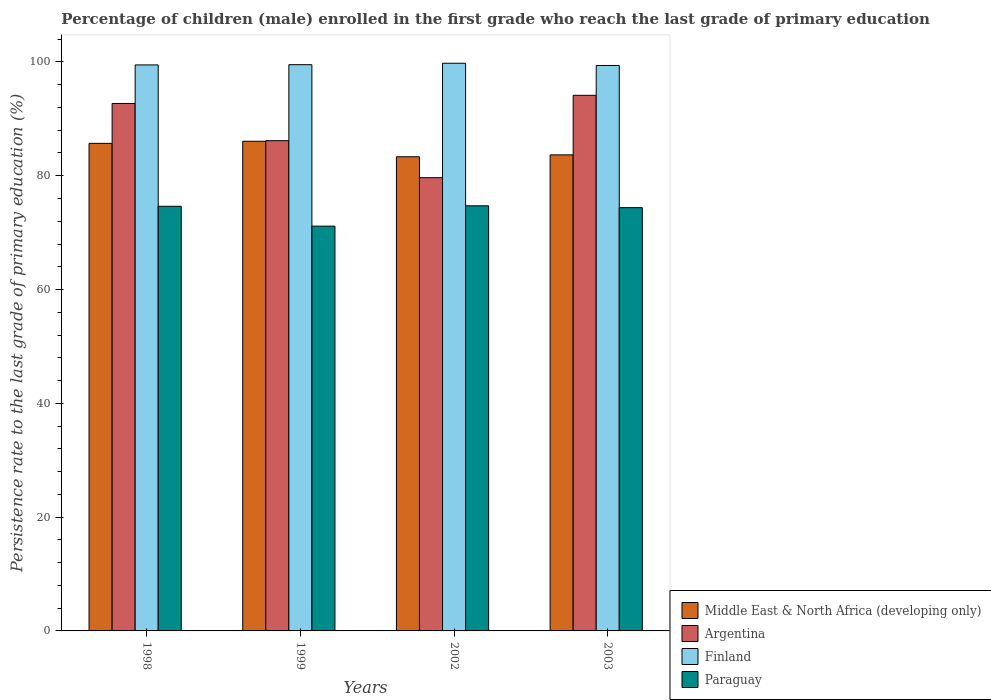How many groups of bars are there?
Make the answer very short. 4. Are the number of bars per tick equal to the number of legend labels?
Make the answer very short. Yes. How many bars are there on the 1st tick from the left?
Offer a terse response. 4. What is the label of the 1st group of bars from the left?
Keep it short and to the point. 1998. In how many cases, is the number of bars for a given year not equal to the number of legend labels?
Your answer should be very brief. 0. What is the persistence rate of children in Finland in 2003?
Provide a succinct answer. 99.38. Across all years, what is the maximum persistence rate of children in Finland?
Provide a succinct answer. 99.77. Across all years, what is the minimum persistence rate of children in Finland?
Offer a very short reply. 99.38. In which year was the persistence rate of children in Paraguay maximum?
Offer a terse response. 2002. In which year was the persistence rate of children in Finland minimum?
Keep it short and to the point. 2003. What is the total persistence rate of children in Paraguay in the graph?
Make the answer very short. 294.88. What is the difference between the persistence rate of children in Paraguay in 1998 and that in 2002?
Keep it short and to the point. -0.09. What is the difference between the persistence rate of children in Middle East & North Africa (developing only) in 2003 and the persistence rate of children in Finland in 1998?
Keep it short and to the point. -15.81. What is the average persistence rate of children in Argentina per year?
Make the answer very short. 88.16. In the year 1998, what is the difference between the persistence rate of children in Paraguay and persistence rate of children in Finland?
Offer a very short reply. -24.85. In how many years, is the persistence rate of children in Finland greater than 32 %?
Offer a very short reply. 4. What is the ratio of the persistence rate of children in Middle East & North Africa (developing only) in 1999 to that in 2002?
Ensure brevity in your answer.  1.03. What is the difference between the highest and the second highest persistence rate of children in Finland?
Offer a terse response. 0.25. What is the difference between the highest and the lowest persistence rate of children in Finland?
Ensure brevity in your answer.  0.39. In how many years, is the persistence rate of children in Paraguay greater than the average persistence rate of children in Paraguay taken over all years?
Provide a short and direct response. 3. Is the sum of the persistence rate of children in Middle East & North Africa (developing only) in 1998 and 1999 greater than the maximum persistence rate of children in Argentina across all years?
Ensure brevity in your answer.  Yes. Is it the case that in every year, the sum of the persistence rate of children in Middle East & North Africa (developing only) and persistence rate of children in Finland is greater than the sum of persistence rate of children in Paraguay and persistence rate of children in Argentina?
Your answer should be very brief. No. What does the 4th bar from the left in 2003 represents?
Offer a very short reply. Paraguay. What does the 4th bar from the right in 2002 represents?
Offer a very short reply. Middle East & North Africa (developing only). Are all the bars in the graph horizontal?
Offer a very short reply. No. How many years are there in the graph?
Your answer should be very brief. 4. What is the difference between two consecutive major ticks on the Y-axis?
Offer a terse response. 20. Does the graph contain any zero values?
Offer a very short reply. No. Does the graph contain grids?
Provide a short and direct response. No. Where does the legend appear in the graph?
Offer a terse response. Bottom right. How many legend labels are there?
Provide a succinct answer. 4. What is the title of the graph?
Your answer should be very brief. Percentage of children (male) enrolled in the first grade who reach the last grade of primary education. Does "Egypt, Arab Rep." appear as one of the legend labels in the graph?
Ensure brevity in your answer.  No. What is the label or title of the Y-axis?
Give a very brief answer. Persistence rate to the last grade of primary education (%). What is the Persistence rate to the last grade of primary education (%) of Middle East & North Africa (developing only) in 1998?
Your answer should be compact. 85.69. What is the Persistence rate to the last grade of primary education (%) of Argentina in 1998?
Give a very brief answer. 92.7. What is the Persistence rate to the last grade of primary education (%) of Finland in 1998?
Ensure brevity in your answer.  99.48. What is the Persistence rate to the last grade of primary education (%) of Paraguay in 1998?
Give a very brief answer. 74.63. What is the Persistence rate to the last grade of primary education (%) in Middle East & North Africa (developing only) in 1999?
Your answer should be compact. 86.06. What is the Persistence rate to the last grade of primary education (%) of Argentina in 1999?
Provide a short and direct response. 86.16. What is the Persistence rate to the last grade of primary education (%) of Finland in 1999?
Provide a succinct answer. 99.52. What is the Persistence rate to the last grade of primary education (%) of Paraguay in 1999?
Keep it short and to the point. 71.14. What is the Persistence rate to the last grade of primary education (%) in Middle East & North Africa (developing only) in 2002?
Your answer should be compact. 83.33. What is the Persistence rate to the last grade of primary education (%) of Argentina in 2002?
Keep it short and to the point. 79.66. What is the Persistence rate to the last grade of primary education (%) of Finland in 2002?
Your response must be concise. 99.77. What is the Persistence rate to the last grade of primary education (%) of Paraguay in 2002?
Ensure brevity in your answer.  74.72. What is the Persistence rate to the last grade of primary education (%) of Middle East & North Africa (developing only) in 2003?
Offer a very short reply. 83.67. What is the Persistence rate to the last grade of primary education (%) of Argentina in 2003?
Your response must be concise. 94.14. What is the Persistence rate to the last grade of primary education (%) of Finland in 2003?
Offer a terse response. 99.38. What is the Persistence rate to the last grade of primary education (%) in Paraguay in 2003?
Make the answer very short. 74.39. Across all years, what is the maximum Persistence rate to the last grade of primary education (%) of Middle East & North Africa (developing only)?
Your answer should be compact. 86.06. Across all years, what is the maximum Persistence rate to the last grade of primary education (%) in Argentina?
Keep it short and to the point. 94.14. Across all years, what is the maximum Persistence rate to the last grade of primary education (%) of Finland?
Your response must be concise. 99.77. Across all years, what is the maximum Persistence rate to the last grade of primary education (%) in Paraguay?
Ensure brevity in your answer.  74.72. Across all years, what is the minimum Persistence rate to the last grade of primary education (%) in Middle East & North Africa (developing only)?
Make the answer very short. 83.33. Across all years, what is the minimum Persistence rate to the last grade of primary education (%) in Argentina?
Provide a short and direct response. 79.66. Across all years, what is the minimum Persistence rate to the last grade of primary education (%) of Finland?
Your answer should be compact. 99.38. Across all years, what is the minimum Persistence rate to the last grade of primary education (%) of Paraguay?
Give a very brief answer. 71.14. What is the total Persistence rate to the last grade of primary education (%) of Middle East & North Africa (developing only) in the graph?
Make the answer very short. 338.76. What is the total Persistence rate to the last grade of primary education (%) in Argentina in the graph?
Offer a very short reply. 352.66. What is the total Persistence rate to the last grade of primary education (%) in Finland in the graph?
Give a very brief answer. 398.14. What is the total Persistence rate to the last grade of primary education (%) of Paraguay in the graph?
Ensure brevity in your answer.  294.88. What is the difference between the Persistence rate to the last grade of primary education (%) of Middle East & North Africa (developing only) in 1998 and that in 1999?
Give a very brief answer. -0.37. What is the difference between the Persistence rate to the last grade of primary education (%) of Argentina in 1998 and that in 1999?
Your answer should be compact. 6.54. What is the difference between the Persistence rate to the last grade of primary education (%) of Finland in 1998 and that in 1999?
Make the answer very short. -0.04. What is the difference between the Persistence rate to the last grade of primary education (%) of Paraguay in 1998 and that in 1999?
Make the answer very short. 3.49. What is the difference between the Persistence rate to the last grade of primary education (%) in Middle East & North Africa (developing only) in 1998 and that in 2002?
Provide a short and direct response. 2.36. What is the difference between the Persistence rate to the last grade of primary education (%) in Argentina in 1998 and that in 2002?
Ensure brevity in your answer.  13.04. What is the difference between the Persistence rate to the last grade of primary education (%) in Finland in 1998 and that in 2002?
Make the answer very short. -0.29. What is the difference between the Persistence rate to the last grade of primary education (%) in Paraguay in 1998 and that in 2002?
Make the answer very short. -0.09. What is the difference between the Persistence rate to the last grade of primary education (%) in Middle East & North Africa (developing only) in 1998 and that in 2003?
Provide a succinct answer. 2.02. What is the difference between the Persistence rate to the last grade of primary education (%) of Argentina in 1998 and that in 2003?
Your answer should be compact. -1.43. What is the difference between the Persistence rate to the last grade of primary education (%) of Finland in 1998 and that in 2003?
Provide a short and direct response. 0.1. What is the difference between the Persistence rate to the last grade of primary education (%) of Paraguay in 1998 and that in 2003?
Give a very brief answer. 0.24. What is the difference between the Persistence rate to the last grade of primary education (%) in Middle East & North Africa (developing only) in 1999 and that in 2002?
Your answer should be very brief. 2.73. What is the difference between the Persistence rate to the last grade of primary education (%) of Argentina in 1999 and that in 2002?
Keep it short and to the point. 6.5. What is the difference between the Persistence rate to the last grade of primary education (%) of Finland in 1999 and that in 2002?
Provide a short and direct response. -0.25. What is the difference between the Persistence rate to the last grade of primary education (%) of Paraguay in 1999 and that in 2002?
Keep it short and to the point. -3.57. What is the difference between the Persistence rate to the last grade of primary education (%) of Middle East & North Africa (developing only) in 1999 and that in 2003?
Provide a short and direct response. 2.39. What is the difference between the Persistence rate to the last grade of primary education (%) in Argentina in 1999 and that in 2003?
Offer a terse response. -7.97. What is the difference between the Persistence rate to the last grade of primary education (%) of Finland in 1999 and that in 2003?
Provide a short and direct response. 0.14. What is the difference between the Persistence rate to the last grade of primary education (%) of Paraguay in 1999 and that in 2003?
Give a very brief answer. -3.25. What is the difference between the Persistence rate to the last grade of primary education (%) in Middle East & North Africa (developing only) in 2002 and that in 2003?
Give a very brief answer. -0.34. What is the difference between the Persistence rate to the last grade of primary education (%) in Argentina in 2002 and that in 2003?
Offer a very short reply. -14.48. What is the difference between the Persistence rate to the last grade of primary education (%) of Finland in 2002 and that in 2003?
Give a very brief answer. 0.39. What is the difference between the Persistence rate to the last grade of primary education (%) of Paraguay in 2002 and that in 2003?
Your response must be concise. 0.33. What is the difference between the Persistence rate to the last grade of primary education (%) of Middle East & North Africa (developing only) in 1998 and the Persistence rate to the last grade of primary education (%) of Argentina in 1999?
Give a very brief answer. -0.47. What is the difference between the Persistence rate to the last grade of primary education (%) of Middle East & North Africa (developing only) in 1998 and the Persistence rate to the last grade of primary education (%) of Finland in 1999?
Ensure brevity in your answer.  -13.83. What is the difference between the Persistence rate to the last grade of primary education (%) in Middle East & North Africa (developing only) in 1998 and the Persistence rate to the last grade of primary education (%) in Paraguay in 1999?
Give a very brief answer. 14.55. What is the difference between the Persistence rate to the last grade of primary education (%) of Argentina in 1998 and the Persistence rate to the last grade of primary education (%) of Finland in 1999?
Provide a short and direct response. -6.82. What is the difference between the Persistence rate to the last grade of primary education (%) of Argentina in 1998 and the Persistence rate to the last grade of primary education (%) of Paraguay in 1999?
Your answer should be compact. 21.56. What is the difference between the Persistence rate to the last grade of primary education (%) in Finland in 1998 and the Persistence rate to the last grade of primary education (%) in Paraguay in 1999?
Your answer should be compact. 28.34. What is the difference between the Persistence rate to the last grade of primary education (%) of Middle East & North Africa (developing only) in 1998 and the Persistence rate to the last grade of primary education (%) of Argentina in 2002?
Make the answer very short. 6.03. What is the difference between the Persistence rate to the last grade of primary education (%) of Middle East & North Africa (developing only) in 1998 and the Persistence rate to the last grade of primary education (%) of Finland in 2002?
Make the answer very short. -14.08. What is the difference between the Persistence rate to the last grade of primary education (%) in Middle East & North Africa (developing only) in 1998 and the Persistence rate to the last grade of primary education (%) in Paraguay in 2002?
Provide a succinct answer. 10.97. What is the difference between the Persistence rate to the last grade of primary education (%) of Argentina in 1998 and the Persistence rate to the last grade of primary education (%) of Finland in 2002?
Give a very brief answer. -7.07. What is the difference between the Persistence rate to the last grade of primary education (%) of Argentina in 1998 and the Persistence rate to the last grade of primary education (%) of Paraguay in 2002?
Your answer should be compact. 17.98. What is the difference between the Persistence rate to the last grade of primary education (%) of Finland in 1998 and the Persistence rate to the last grade of primary education (%) of Paraguay in 2002?
Give a very brief answer. 24.76. What is the difference between the Persistence rate to the last grade of primary education (%) in Middle East & North Africa (developing only) in 1998 and the Persistence rate to the last grade of primary education (%) in Argentina in 2003?
Make the answer very short. -8.45. What is the difference between the Persistence rate to the last grade of primary education (%) of Middle East & North Africa (developing only) in 1998 and the Persistence rate to the last grade of primary education (%) of Finland in 2003?
Make the answer very short. -13.69. What is the difference between the Persistence rate to the last grade of primary education (%) in Argentina in 1998 and the Persistence rate to the last grade of primary education (%) in Finland in 2003?
Your response must be concise. -6.68. What is the difference between the Persistence rate to the last grade of primary education (%) in Argentina in 1998 and the Persistence rate to the last grade of primary education (%) in Paraguay in 2003?
Provide a short and direct response. 18.31. What is the difference between the Persistence rate to the last grade of primary education (%) of Finland in 1998 and the Persistence rate to the last grade of primary education (%) of Paraguay in 2003?
Give a very brief answer. 25.09. What is the difference between the Persistence rate to the last grade of primary education (%) of Middle East & North Africa (developing only) in 1999 and the Persistence rate to the last grade of primary education (%) of Argentina in 2002?
Give a very brief answer. 6.4. What is the difference between the Persistence rate to the last grade of primary education (%) in Middle East & North Africa (developing only) in 1999 and the Persistence rate to the last grade of primary education (%) in Finland in 2002?
Make the answer very short. -13.71. What is the difference between the Persistence rate to the last grade of primary education (%) of Middle East & North Africa (developing only) in 1999 and the Persistence rate to the last grade of primary education (%) of Paraguay in 2002?
Keep it short and to the point. 11.35. What is the difference between the Persistence rate to the last grade of primary education (%) in Argentina in 1999 and the Persistence rate to the last grade of primary education (%) in Finland in 2002?
Your answer should be very brief. -13.61. What is the difference between the Persistence rate to the last grade of primary education (%) of Argentina in 1999 and the Persistence rate to the last grade of primary education (%) of Paraguay in 2002?
Make the answer very short. 11.45. What is the difference between the Persistence rate to the last grade of primary education (%) of Finland in 1999 and the Persistence rate to the last grade of primary education (%) of Paraguay in 2002?
Provide a short and direct response. 24.8. What is the difference between the Persistence rate to the last grade of primary education (%) in Middle East & North Africa (developing only) in 1999 and the Persistence rate to the last grade of primary education (%) in Argentina in 2003?
Ensure brevity in your answer.  -8.07. What is the difference between the Persistence rate to the last grade of primary education (%) of Middle East & North Africa (developing only) in 1999 and the Persistence rate to the last grade of primary education (%) of Finland in 2003?
Make the answer very short. -13.31. What is the difference between the Persistence rate to the last grade of primary education (%) of Middle East & North Africa (developing only) in 1999 and the Persistence rate to the last grade of primary education (%) of Paraguay in 2003?
Offer a terse response. 11.67. What is the difference between the Persistence rate to the last grade of primary education (%) in Argentina in 1999 and the Persistence rate to the last grade of primary education (%) in Finland in 2003?
Provide a short and direct response. -13.21. What is the difference between the Persistence rate to the last grade of primary education (%) of Argentina in 1999 and the Persistence rate to the last grade of primary education (%) of Paraguay in 2003?
Provide a succinct answer. 11.77. What is the difference between the Persistence rate to the last grade of primary education (%) of Finland in 1999 and the Persistence rate to the last grade of primary education (%) of Paraguay in 2003?
Keep it short and to the point. 25.13. What is the difference between the Persistence rate to the last grade of primary education (%) of Middle East & North Africa (developing only) in 2002 and the Persistence rate to the last grade of primary education (%) of Argentina in 2003?
Your answer should be compact. -10.8. What is the difference between the Persistence rate to the last grade of primary education (%) in Middle East & North Africa (developing only) in 2002 and the Persistence rate to the last grade of primary education (%) in Finland in 2003?
Provide a short and direct response. -16.04. What is the difference between the Persistence rate to the last grade of primary education (%) in Middle East & North Africa (developing only) in 2002 and the Persistence rate to the last grade of primary education (%) in Paraguay in 2003?
Ensure brevity in your answer.  8.94. What is the difference between the Persistence rate to the last grade of primary education (%) of Argentina in 2002 and the Persistence rate to the last grade of primary education (%) of Finland in 2003?
Your answer should be compact. -19.72. What is the difference between the Persistence rate to the last grade of primary education (%) of Argentina in 2002 and the Persistence rate to the last grade of primary education (%) of Paraguay in 2003?
Ensure brevity in your answer.  5.27. What is the difference between the Persistence rate to the last grade of primary education (%) of Finland in 2002 and the Persistence rate to the last grade of primary education (%) of Paraguay in 2003?
Provide a short and direct response. 25.38. What is the average Persistence rate to the last grade of primary education (%) in Middle East & North Africa (developing only) per year?
Give a very brief answer. 84.69. What is the average Persistence rate to the last grade of primary education (%) of Argentina per year?
Your answer should be compact. 88.16. What is the average Persistence rate to the last grade of primary education (%) in Finland per year?
Keep it short and to the point. 99.54. What is the average Persistence rate to the last grade of primary education (%) of Paraguay per year?
Your answer should be compact. 73.72. In the year 1998, what is the difference between the Persistence rate to the last grade of primary education (%) of Middle East & North Africa (developing only) and Persistence rate to the last grade of primary education (%) of Argentina?
Offer a very short reply. -7.01. In the year 1998, what is the difference between the Persistence rate to the last grade of primary education (%) in Middle East & North Africa (developing only) and Persistence rate to the last grade of primary education (%) in Finland?
Offer a terse response. -13.79. In the year 1998, what is the difference between the Persistence rate to the last grade of primary education (%) in Middle East & North Africa (developing only) and Persistence rate to the last grade of primary education (%) in Paraguay?
Keep it short and to the point. 11.06. In the year 1998, what is the difference between the Persistence rate to the last grade of primary education (%) in Argentina and Persistence rate to the last grade of primary education (%) in Finland?
Your answer should be compact. -6.78. In the year 1998, what is the difference between the Persistence rate to the last grade of primary education (%) of Argentina and Persistence rate to the last grade of primary education (%) of Paraguay?
Ensure brevity in your answer.  18.07. In the year 1998, what is the difference between the Persistence rate to the last grade of primary education (%) in Finland and Persistence rate to the last grade of primary education (%) in Paraguay?
Ensure brevity in your answer.  24.85. In the year 1999, what is the difference between the Persistence rate to the last grade of primary education (%) in Middle East & North Africa (developing only) and Persistence rate to the last grade of primary education (%) in Argentina?
Provide a short and direct response. -0.1. In the year 1999, what is the difference between the Persistence rate to the last grade of primary education (%) of Middle East & North Africa (developing only) and Persistence rate to the last grade of primary education (%) of Finland?
Make the answer very short. -13.46. In the year 1999, what is the difference between the Persistence rate to the last grade of primary education (%) in Middle East & North Africa (developing only) and Persistence rate to the last grade of primary education (%) in Paraguay?
Make the answer very short. 14.92. In the year 1999, what is the difference between the Persistence rate to the last grade of primary education (%) of Argentina and Persistence rate to the last grade of primary education (%) of Finland?
Your response must be concise. -13.35. In the year 1999, what is the difference between the Persistence rate to the last grade of primary education (%) in Argentina and Persistence rate to the last grade of primary education (%) in Paraguay?
Your response must be concise. 15.02. In the year 1999, what is the difference between the Persistence rate to the last grade of primary education (%) of Finland and Persistence rate to the last grade of primary education (%) of Paraguay?
Make the answer very short. 28.38. In the year 2002, what is the difference between the Persistence rate to the last grade of primary education (%) of Middle East & North Africa (developing only) and Persistence rate to the last grade of primary education (%) of Argentina?
Your answer should be compact. 3.67. In the year 2002, what is the difference between the Persistence rate to the last grade of primary education (%) of Middle East & North Africa (developing only) and Persistence rate to the last grade of primary education (%) of Finland?
Ensure brevity in your answer.  -16.44. In the year 2002, what is the difference between the Persistence rate to the last grade of primary education (%) in Middle East & North Africa (developing only) and Persistence rate to the last grade of primary education (%) in Paraguay?
Offer a very short reply. 8.62. In the year 2002, what is the difference between the Persistence rate to the last grade of primary education (%) of Argentina and Persistence rate to the last grade of primary education (%) of Finland?
Give a very brief answer. -20.11. In the year 2002, what is the difference between the Persistence rate to the last grade of primary education (%) in Argentina and Persistence rate to the last grade of primary education (%) in Paraguay?
Make the answer very short. 4.94. In the year 2002, what is the difference between the Persistence rate to the last grade of primary education (%) in Finland and Persistence rate to the last grade of primary education (%) in Paraguay?
Your response must be concise. 25.05. In the year 2003, what is the difference between the Persistence rate to the last grade of primary education (%) in Middle East & North Africa (developing only) and Persistence rate to the last grade of primary education (%) in Argentina?
Provide a succinct answer. -10.46. In the year 2003, what is the difference between the Persistence rate to the last grade of primary education (%) in Middle East & North Africa (developing only) and Persistence rate to the last grade of primary education (%) in Finland?
Provide a short and direct response. -15.71. In the year 2003, what is the difference between the Persistence rate to the last grade of primary education (%) of Middle East & North Africa (developing only) and Persistence rate to the last grade of primary education (%) of Paraguay?
Your response must be concise. 9.28. In the year 2003, what is the difference between the Persistence rate to the last grade of primary education (%) in Argentina and Persistence rate to the last grade of primary education (%) in Finland?
Provide a succinct answer. -5.24. In the year 2003, what is the difference between the Persistence rate to the last grade of primary education (%) in Argentina and Persistence rate to the last grade of primary education (%) in Paraguay?
Give a very brief answer. 19.75. In the year 2003, what is the difference between the Persistence rate to the last grade of primary education (%) in Finland and Persistence rate to the last grade of primary education (%) in Paraguay?
Ensure brevity in your answer.  24.99. What is the ratio of the Persistence rate to the last grade of primary education (%) of Argentina in 1998 to that in 1999?
Offer a terse response. 1.08. What is the ratio of the Persistence rate to the last grade of primary education (%) of Paraguay in 1998 to that in 1999?
Provide a succinct answer. 1.05. What is the ratio of the Persistence rate to the last grade of primary education (%) of Middle East & North Africa (developing only) in 1998 to that in 2002?
Give a very brief answer. 1.03. What is the ratio of the Persistence rate to the last grade of primary education (%) of Argentina in 1998 to that in 2002?
Your answer should be very brief. 1.16. What is the ratio of the Persistence rate to the last grade of primary education (%) in Middle East & North Africa (developing only) in 1998 to that in 2003?
Offer a very short reply. 1.02. What is the ratio of the Persistence rate to the last grade of primary education (%) in Argentina in 1998 to that in 2003?
Provide a succinct answer. 0.98. What is the ratio of the Persistence rate to the last grade of primary education (%) in Middle East & North Africa (developing only) in 1999 to that in 2002?
Offer a terse response. 1.03. What is the ratio of the Persistence rate to the last grade of primary education (%) of Argentina in 1999 to that in 2002?
Your answer should be very brief. 1.08. What is the ratio of the Persistence rate to the last grade of primary education (%) of Paraguay in 1999 to that in 2002?
Your answer should be very brief. 0.95. What is the ratio of the Persistence rate to the last grade of primary education (%) in Middle East & North Africa (developing only) in 1999 to that in 2003?
Ensure brevity in your answer.  1.03. What is the ratio of the Persistence rate to the last grade of primary education (%) of Argentina in 1999 to that in 2003?
Your answer should be compact. 0.92. What is the ratio of the Persistence rate to the last grade of primary education (%) in Finland in 1999 to that in 2003?
Your response must be concise. 1. What is the ratio of the Persistence rate to the last grade of primary education (%) of Paraguay in 1999 to that in 2003?
Your answer should be compact. 0.96. What is the ratio of the Persistence rate to the last grade of primary education (%) of Argentina in 2002 to that in 2003?
Your response must be concise. 0.85. What is the ratio of the Persistence rate to the last grade of primary education (%) in Finland in 2002 to that in 2003?
Provide a short and direct response. 1. What is the difference between the highest and the second highest Persistence rate to the last grade of primary education (%) in Middle East & North Africa (developing only)?
Your answer should be compact. 0.37. What is the difference between the highest and the second highest Persistence rate to the last grade of primary education (%) in Argentina?
Ensure brevity in your answer.  1.43. What is the difference between the highest and the second highest Persistence rate to the last grade of primary education (%) of Finland?
Give a very brief answer. 0.25. What is the difference between the highest and the second highest Persistence rate to the last grade of primary education (%) of Paraguay?
Offer a very short reply. 0.09. What is the difference between the highest and the lowest Persistence rate to the last grade of primary education (%) in Middle East & North Africa (developing only)?
Give a very brief answer. 2.73. What is the difference between the highest and the lowest Persistence rate to the last grade of primary education (%) in Argentina?
Give a very brief answer. 14.48. What is the difference between the highest and the lowest Persistence rate to the last grade of primary education (%) of Finland?
Offer a terse response. 0.39. What is the difference between the highest and the lowest Persistence rate to the last grade of primary education (%) of Paraguay?
Provide a short and direct response. 3.57. 